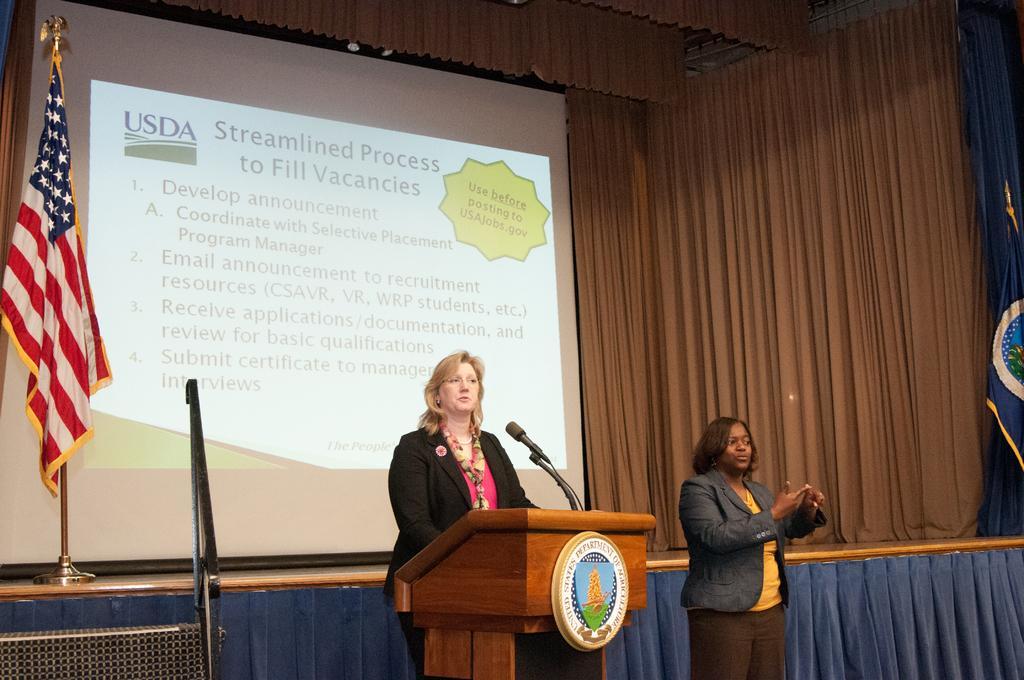Describe this image in one or two sentences. In the foreground I can see two women are standing on the stage in front of a table and mike. In the background I can see a curtain, flag and screen. This image is taken in a hall. 